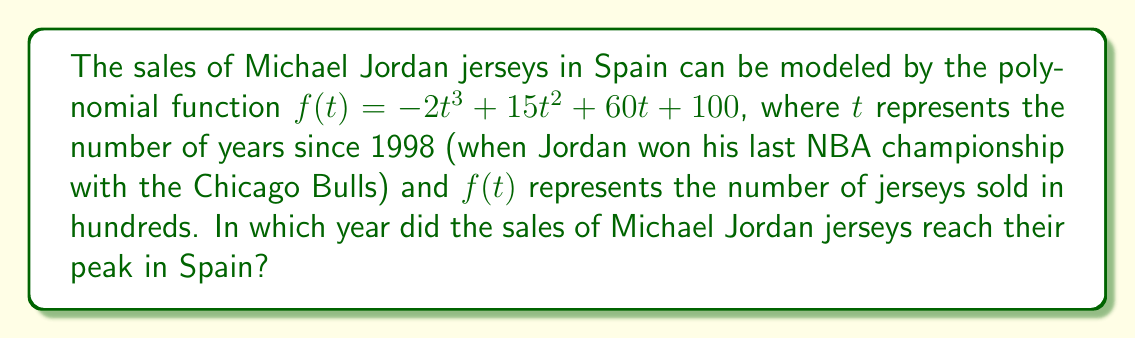What is the answer to this math problem? To find the year when sales peaked, we need to follow these steps:

1) First, we need to find the maximum point of the function. This occurs when the derivative of the function equals zero.

2) Let's find the derivative of $f(t)$:
   $f'(t) = -6t^2 + 30t + 60$

3) Set the derivative equal to zero and solve for $t$:
   $-6t^2 + 30t + 60 = 0$

4) This is a quadratic equation. We can solve it using the quadratic formula:
   $t = \frac{-b \pm \sqrt{b^2 - 4ac}}{2a}$

   Where $a = -6$, $b = 30$, and $c = 60$

5) Plugging in these values:
   $t = \frac{-30 \pm \sqrt{30^2 - 4(-6)(60)}}{2(-6)}$
   $= \frac{-30 \pm \sqrt{900 + 1440}}{-12}$
   $= \frac{-30 \pm \sqrt{2340}}{-12}$
   $= \frac{-30 \pm 48.37}{-12}$

6) This gives us two solutions:
   $t_1 = \frac{-30 + 48.37}{-12} \approx 1.53$
   $t_2 = \frac{-30 - 48.37}{-12} \approx 6.53$

7) The second solution (6.53) is outside our domain (as $t$ starts from 0 in 1998), so we use the first solution.

8) $t \approx 1.53$ years after 1998 is approximately mid-1999.

Therefore, the sales of Michael Jordan jerseys in Spain peaked in 1999.
Answer: 1999 